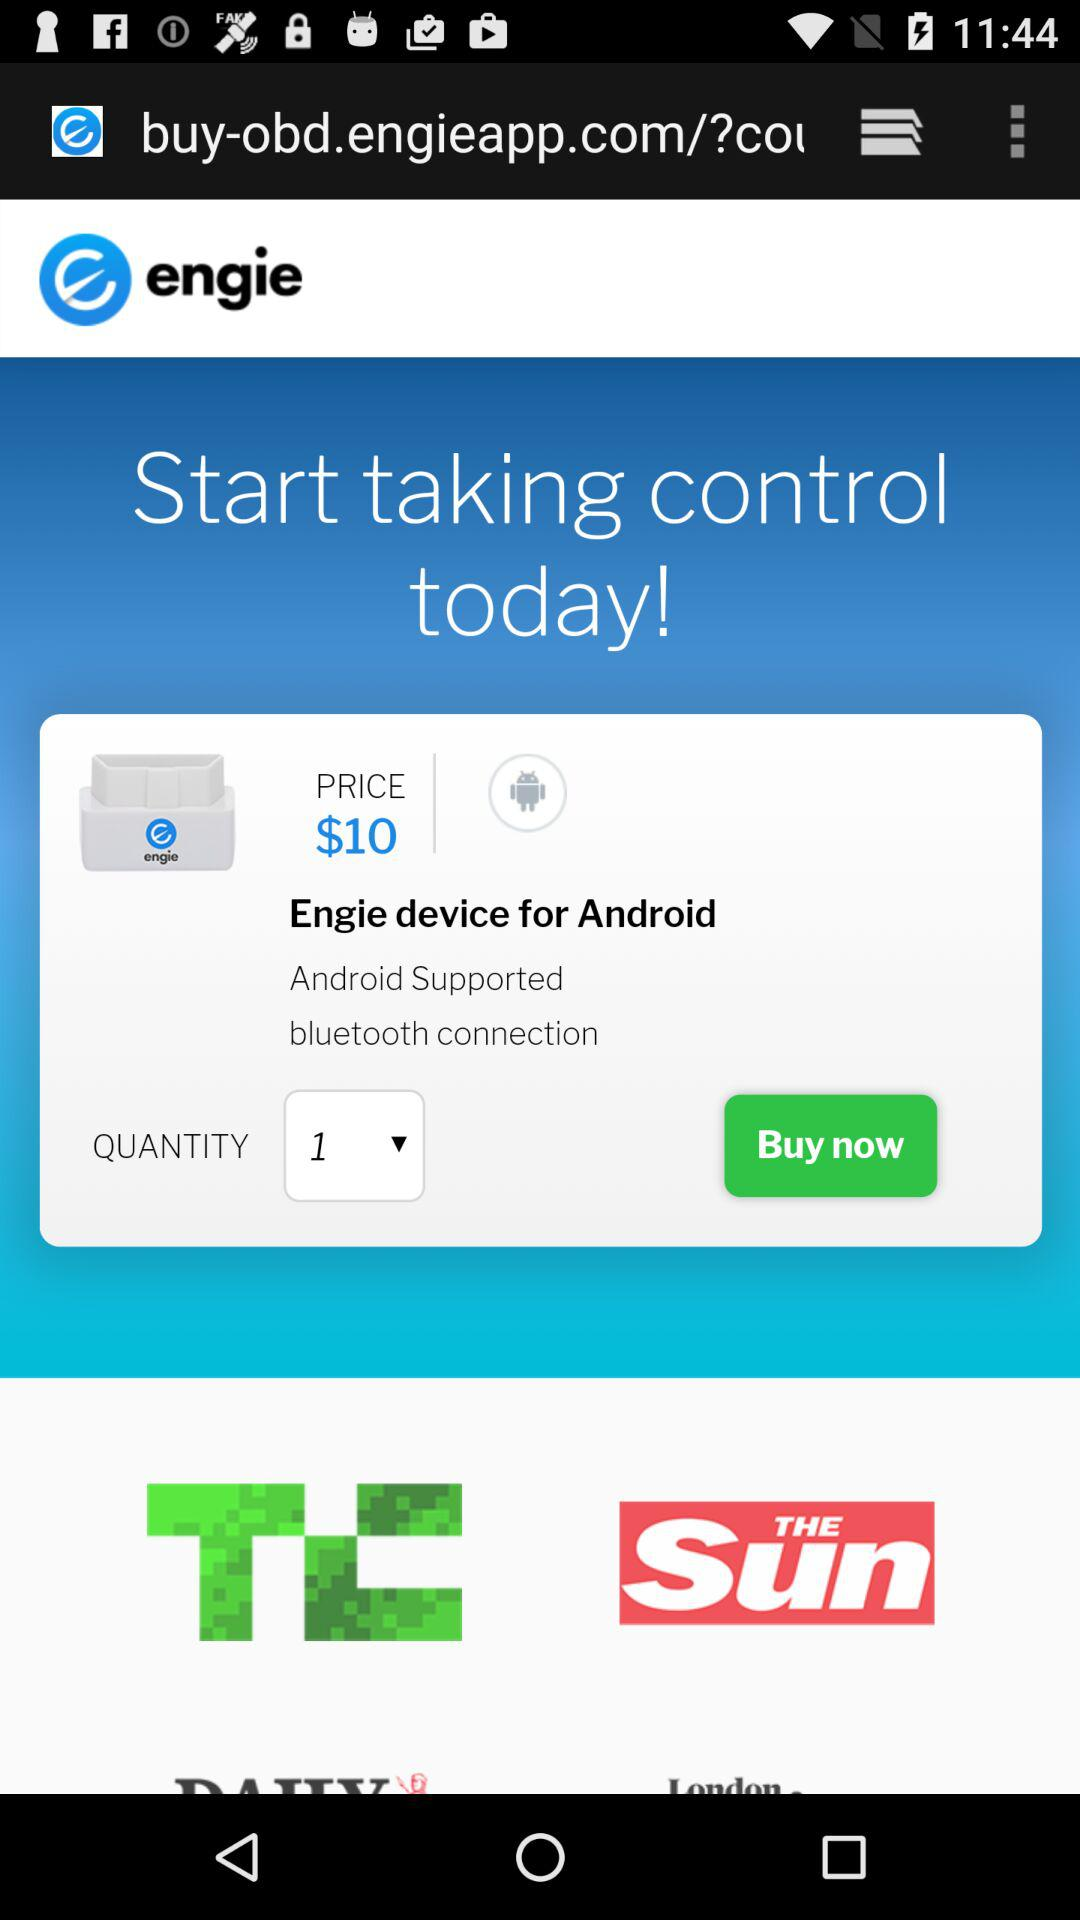How can the device be connected? The device can be connected via Bluetooth. 